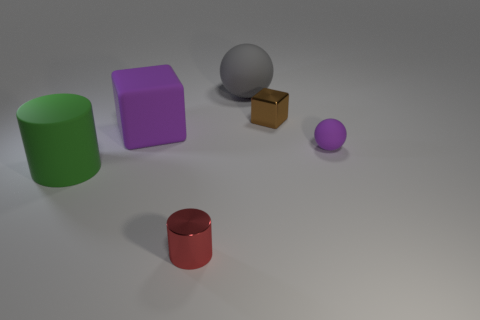Subtract 2 cylinders. How many cylinders are left? 0 Subtract all purple blocks. How many blocks are left? 1 Subtract all yellow cubes. How many purple spheres are left? 1 Add 1 purple cubes. How many purple cubes exist? 2 Add 4 green objects. How many objects exist? 10 Subtract 1 purple balls. How many objects are left? 5 Subtract all cylinders. How many objects are left? 4 Subtract all purple cylinders. Subtract all brown spheres. How many cylinders are left? 2 Subtract all purple cubes. Subtract all matte balls. How many objects are left? 3 Add 6 brown objects. How many brown objects are left? 7 